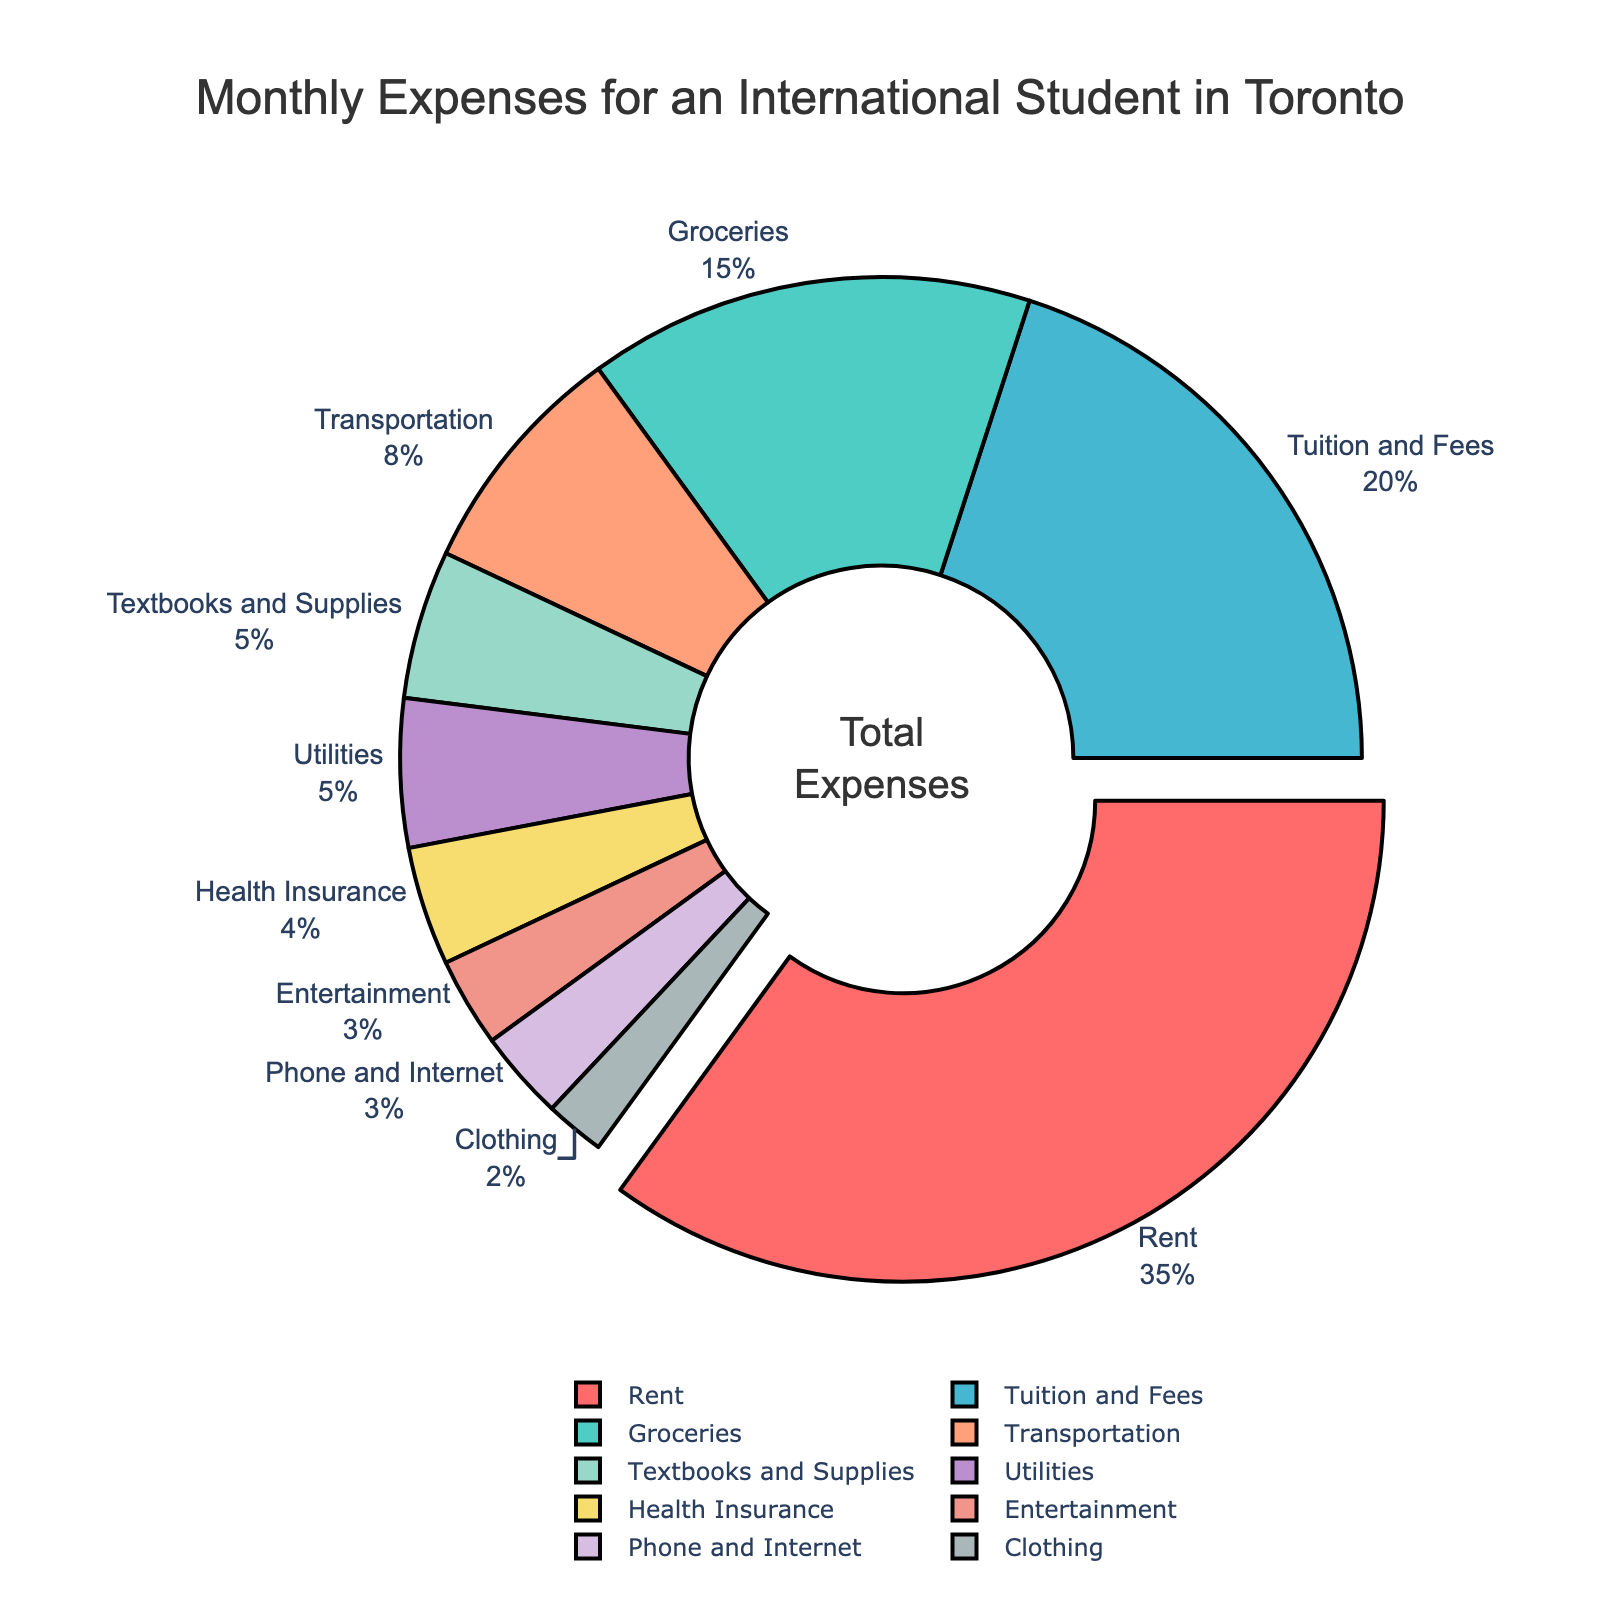What percentage of the monthly expenses is spent on Rent? The pie chart shows different categories of expenses with their respective percentages. From the chart, the percentage for Rent is indicated as 35%.
Answer: 35% How much more is spent on Rent compared to Groceries? To find the difference between expenses on Rent and Groceries, subtract the percentage of Groceries from Rent. Rent is 35% and Groceries is 15%. So, 35% - 15% = 20%.
Answer: 20% Which category has the smallest allocation? The category with the smallest allocation is indicated by examining the percentages. Clothing has the smallest allocation of 2%.
Answer: Clothing What is the combined percentage for Tuition and Fees and Entertainment? To find the combined percentage, add the percentages of Tuition and Fees and Entertainment. Tuition and Fees is 20% and Entertainment is 3%. So, 20% + 3% = 23%.
Answer: 23% Is more money spent on Transportation or Health Insurance? By comparing the percentages of Transportation and Health Insurance, we see that Transportation is 8% and Health Insurance is 4%. Thus, more money is spent on Transportation.
Answer: Transportation Which category is highlighted or pulled out in the pie chart? The pie chart visually emphasizes a category by pulling it out. The category with the highest percentage, Rent, is pulled out in the chart.
Answer: Rent How does the expense on Textbooks and Supplies compare to the expense on Utilities? Compare the percentages for Textbooks and Supplies and Utilities. Both categories are shown with a percentage of 5%.
Answer: Equal What is the total percentage spent on Phone and Internet, and Entertainment combined? Add the percentages of Phone and Internet and Entertainment. Phone and Internet is 3% and Entertainment is 3%. So, 3% + 3% = 6%.
Answer: 6% What percentage of expenses is spent on categories other than Rent? To find the percentage spent on categories other than Rent, subtract Rent's percentage from 100%. Rent is 35%, so 100% - 35% = 65%.
Answer: 65% If the total monthly expenses are $2000, how much is spent on Groceries? First, calculate the percentage of Groceries, which is 15%. Then, find 15% of $2000. ($2000 * 15/100) = $300.
Answer: $300 